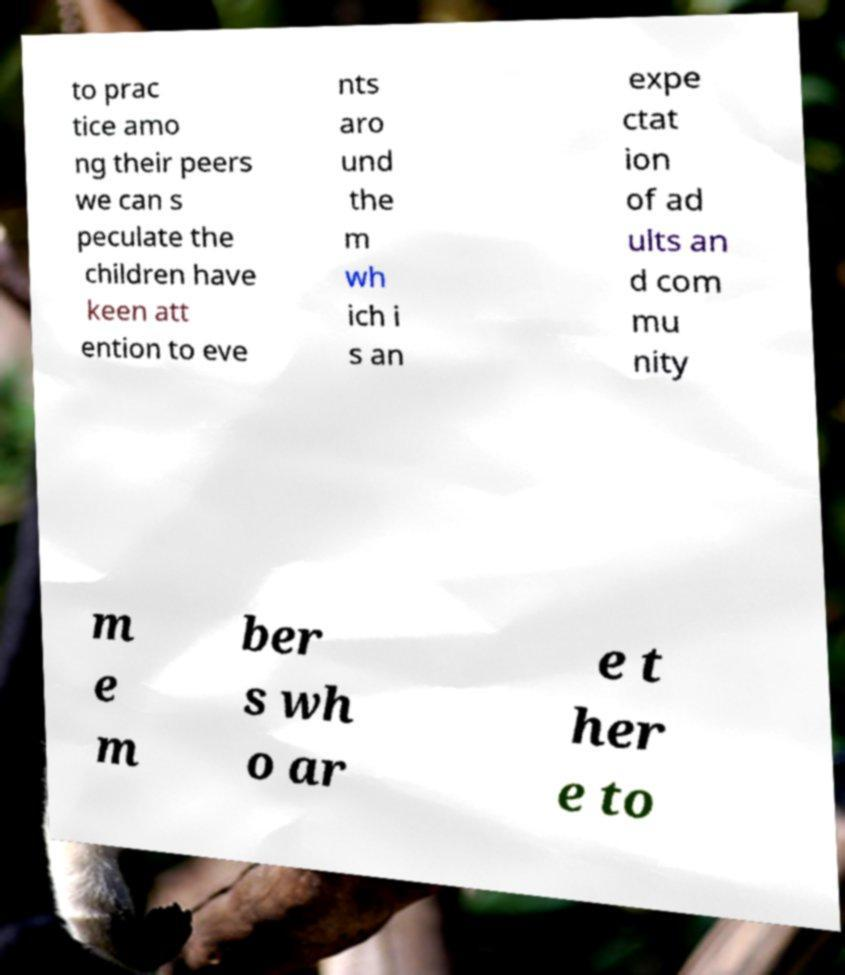There's text embedded in this image that I need extracted. Can you transcribe it verbatim? to prac tice amo ng their peers we can s peculate the children have keen att ention to eve nts aro und the m wh ich i s an expe ctat ion of ad ults an d com mu nity m e m ber s wh o ar e t her e to 